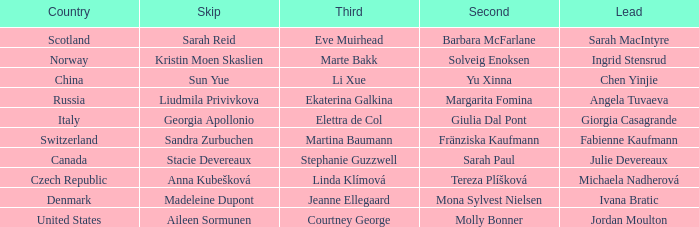Which skip specifies switzerland as the country? Sandra Zurbuchen. 